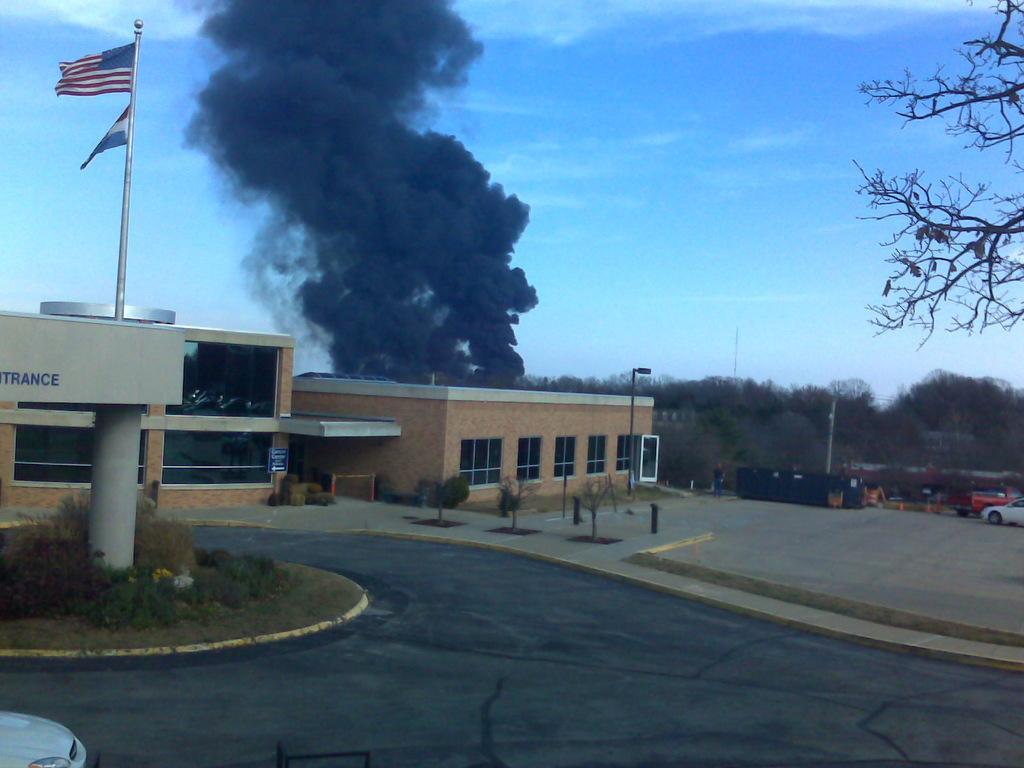Could you give a brief overview of what you see in this image? In this image we can see a building. There is a smoke in the image. There is a road in the image. There are two flags in the image. There are few vehicles in the image. There is a car at the bottom of the image. There is a blue sky in the image. There is a grassy land in the image. There are many plants and trees in the image. There is some text on the wall at the left side of the image. There are few poles in the image. 